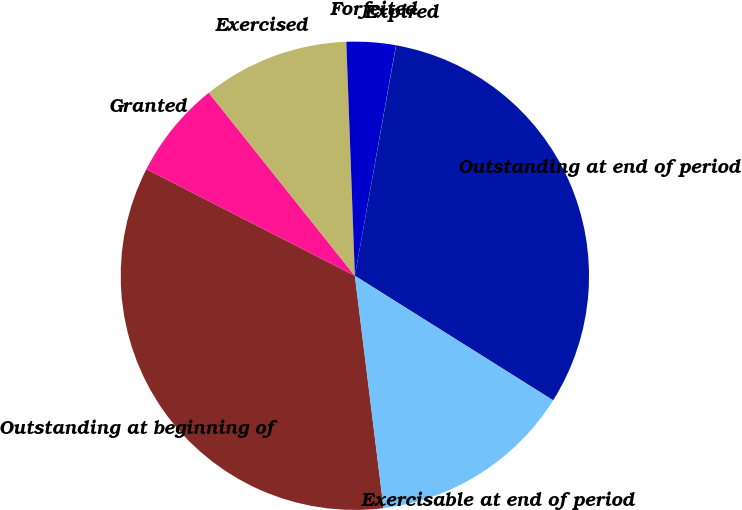Convert chart. <chart><loc_0><loc_0><loc_500><loc_500><pie_chart><fcel>Outstanding at beginning of<fcel>Granted<fcel>Exercised<fcel>Forfeited<fcel>Expired<fcel>Outstanding at end of period<fcel>Exercisable at end of period<nl><fcel>34.48%<fcel>6.76%<fcel>10.14%<fcel>3.39%<fcel>0.01%<fcel>31.11%<fcel>14.12%<nl></chart> 